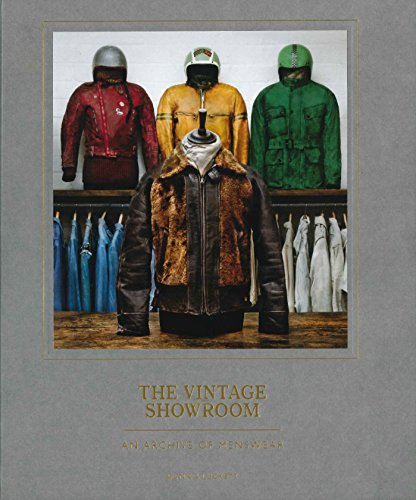What is the genre of this book? The genre of 'The Vintage Showroom: Vintage Menswear 2' is primarily focused on fashion, particularly historical and vintage menswear, offering insights and photographs detailing the evolution of men's attire. 